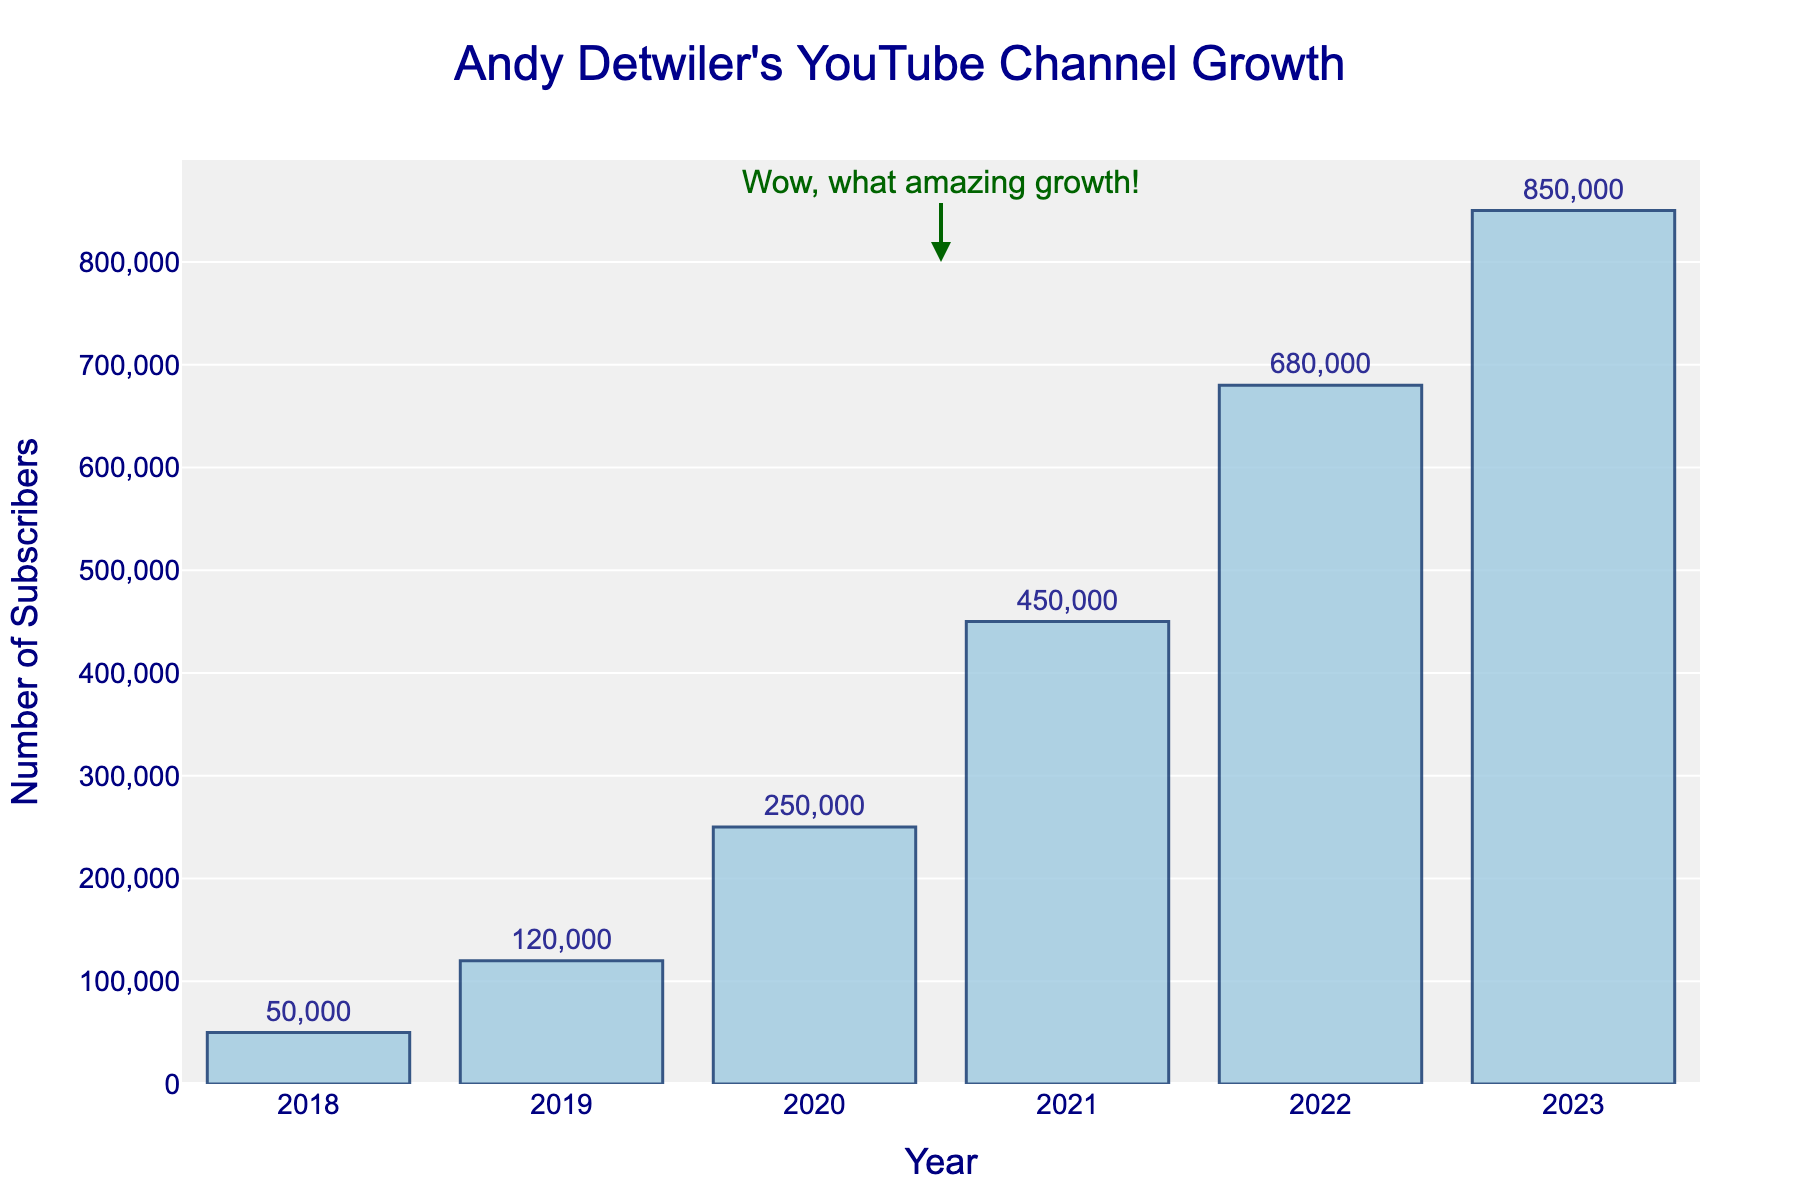What is the total number of subscribers gained from 2018 to 2023? To find the total number of subscribers gained over this period, sum the subscriber counts for each year: 50,000 + 120,000 + 250,000 + 450,000 + 680,000 + 850,000. This gives 2,400,000 subscribers in total.
Answer: 2,400,000 Which year had the highest subscriber count? By referring to the heights of the bars in the figure, you can see that the year with the highest subscriber count is 2023 with 850,000 subscribers.
Answer: 2023 How many more subscribers did Andy Detwiler's channel gain in 2020 compared to 2018? To find the difference in subscriber counts between 2020 and 2018, subtract the 2018 count from the 2020 count: 250,000 - 50,000 = 200,000.
Answer: 200,000 Which year saw the largest increase in subscriber count compared to the previous year? Calculate the year-over-year differences:
2019: 120,000 - 50,000 = 70,000
2020: 250,000 - 120,000 = 130,000
2021: 450,000 - 250,000 = 200,000
2022: 680,000 - 450,000 = 230,000
2023: 850,000 - 680,000 = 170,000
The largest increase was from 2021 to 2022, with a gain of 230,000 subscribers.
Answer: 2022 What is the average annual subscriber count over these five years? Sum the subscriber counts and divide by the number of years: 
(50,000 + 120,000 + 250,000 + 450,000 + 680,000 + 850,000) / 6 = 2,400,000 / 6 = 400,000.
Answer: 400,000 What is the increase in subscriber count from 2018 to 2023 expressed as a percentage? Calculate the percentage increase using the formula:
((final value - initial value) / initial value) * 100 
((850,000 - 50,000) / 50,000) * 100 = 1600%.
Answer: 1600% In which year did the channel reach exactly 250,000 subscribers? By referring to the bars, we see that in 2020, the number of subscribers reached exactly 250,000.
Answer: 2020 How does the subscriber count in 2023 compare to the subscriber count in 2021? Subtract the count in 2021 from the count in 2023 to find the difference:
850,000 - 450,000 = 400,000. So, 2023 has 400,000 more subscribers than 2021.
Answer: 400,000 What is the median number of subscribers from 2018 to 2023? Arrange the subscriber counts in ascending order: 50,000, 120,000, 250,000, 450,000, 680,000, 850,000. There are 6 values, so the median is the average of the 3rd and 4th values: (250,000 + 450,000) / 2 = 350,000.
Answer: 350,000 